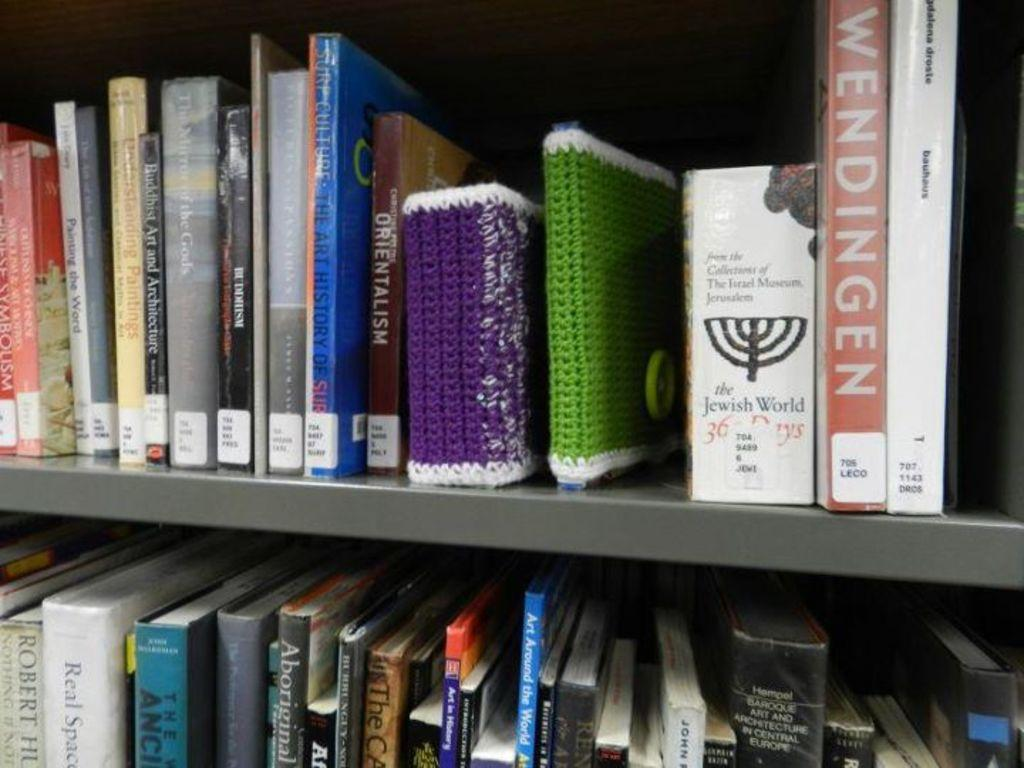<image>
Present a compact description of the photo's key features. Shelves of books stacked beside each other with the book Wendingen at the end. 